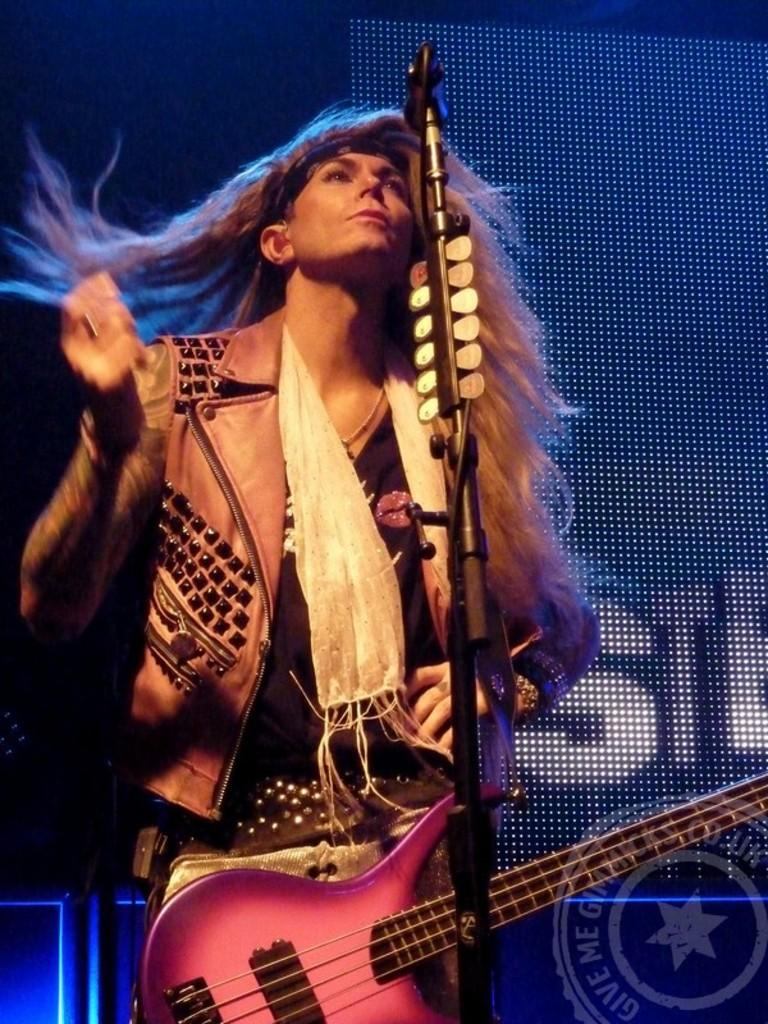What is the main subject of the image? There is a person in the image. What is the person doing in the image? The person is playing the guitar. What is the person wearing in the image? The person is wearing a coat. What is the person's posture in the image? The person is standing. Can you see the person's toes in the image? There is no indication of the person's toes in the image, as they are not visible. 